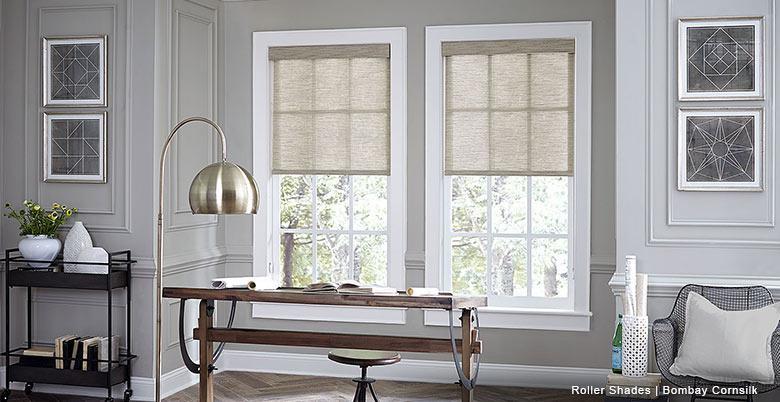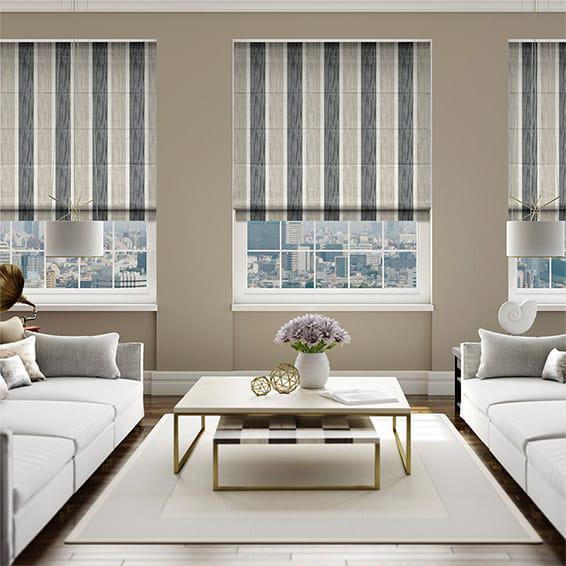The first image is the image on the left, the second image is the image on the right. Analyze the images presented: Is the assertion "All the window shades are partially open." valid? Answer yes or no. Yes. The first image is the image on the left, the second image is the image on the right. Given the left and right images, does the statement "There are five blinds." hold true? Answer yes or no. Yes. 